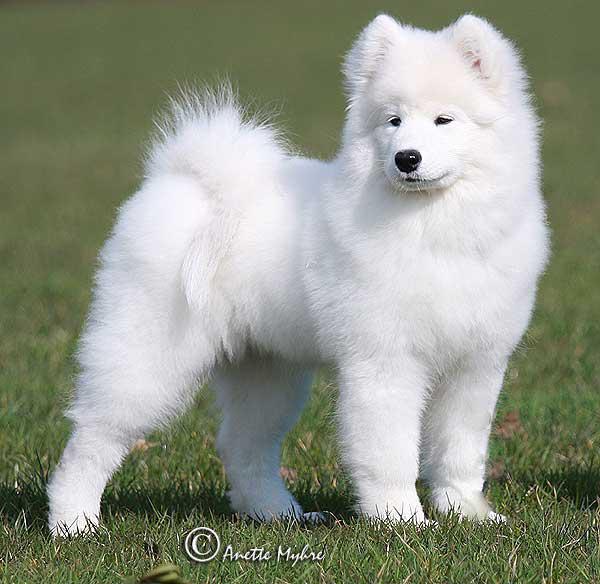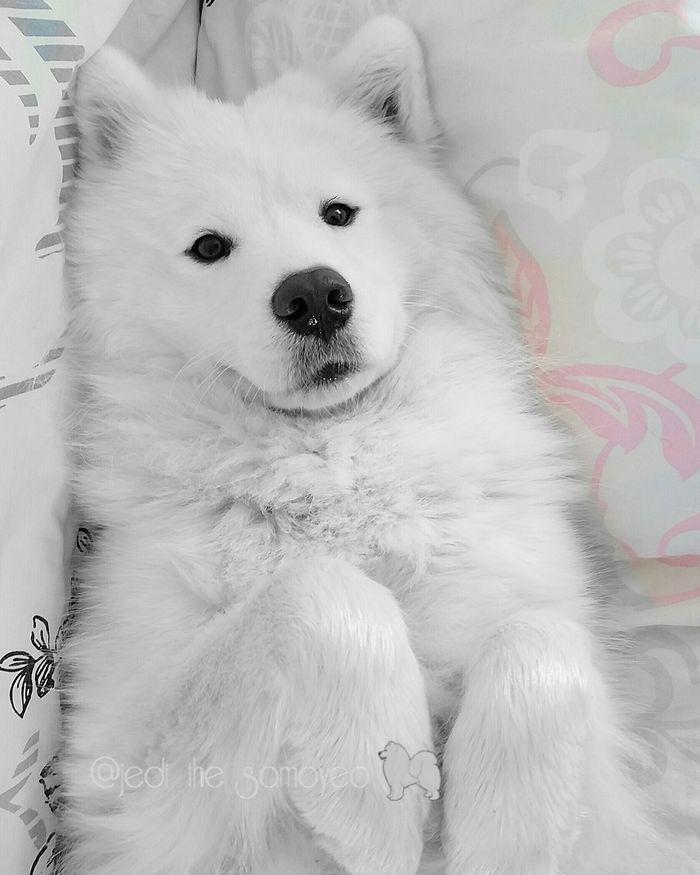The first image is the image on the left, the second image is the image on the right. Evaluate the accuracy of this statement regarding the images: "At least one image shows a white dog standing on all fours in the grass.". Is it true? Answer yes or no. Yes. The first image is the image on the left, the second image is the image on the right. Analyze the images presented: Is the assertion "The dog in the left photo has its tongue out." valid? Answer yes or no. No. 